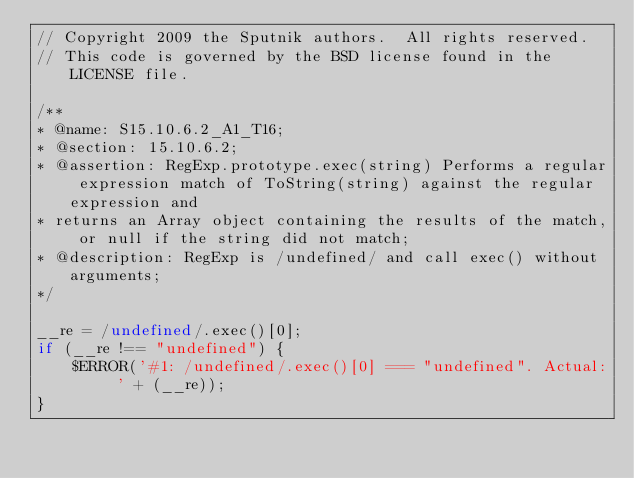<code> <loc_0><loc_0><loc_500><loc_500><_JavaScript_>// Copyright 2009 the Sputnik authors.  All rights reserved.
// This code is governed by the BSD license found in the LICENSE file.

/**
* @name: S15.10.6.2_A1_T16;
* @section: 15.10.6.2;
* @assertion: RegExp.prototype.exec(string) Performs a regular expression match of ToString(string) against the regular expression and 
* returns an Array object containing the results of the match, or null if the string did not match;
* @description: RegExp is /undefined/ and call exec() without arguments;
*/

__re = /undefined/.exec()[0];
if (__re !== "undefined") {
	$ERROR('#1: /undefined/.exec()[0] === "undefined". Actual: ' + (__re));
}

</code> 